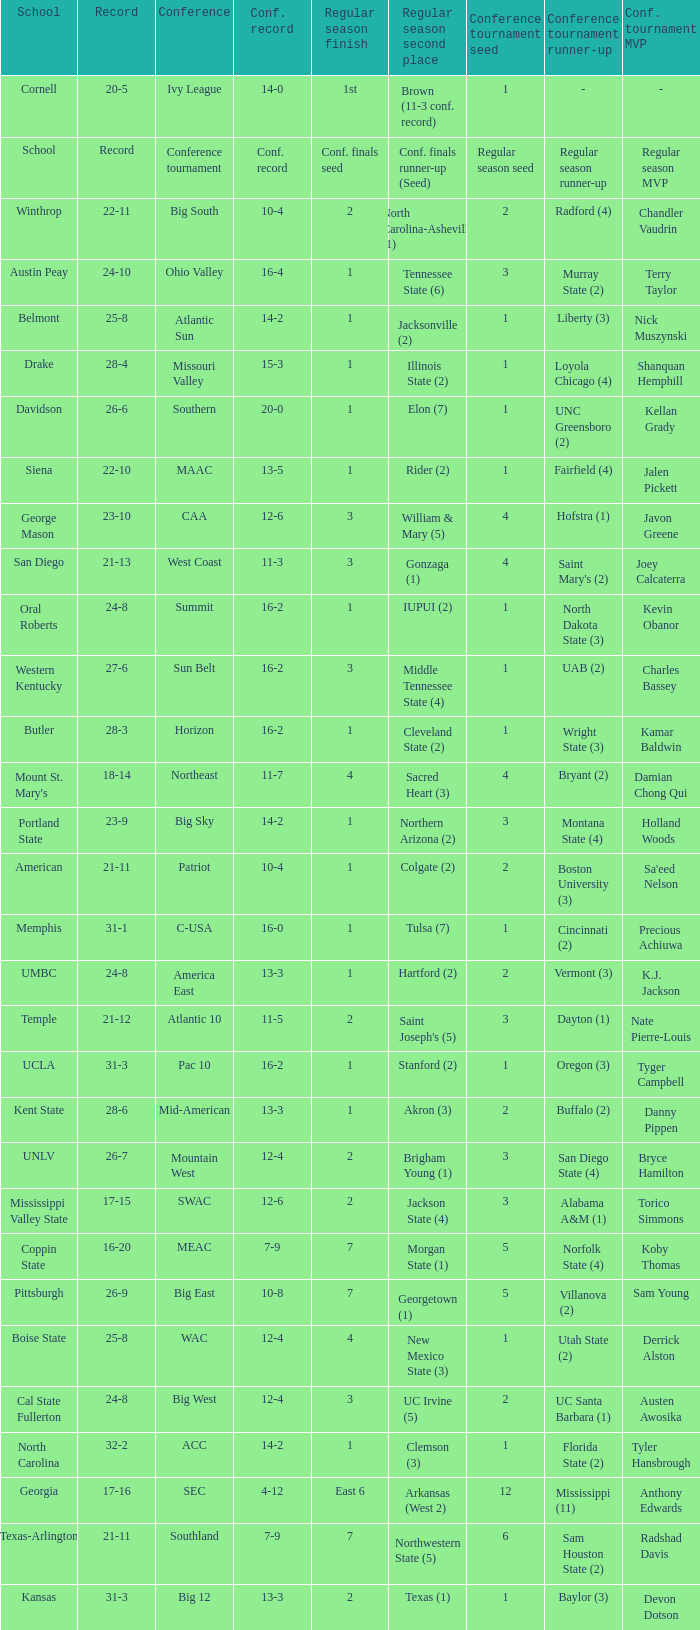What was the overall record of Oral Roberts college? 24-8. 